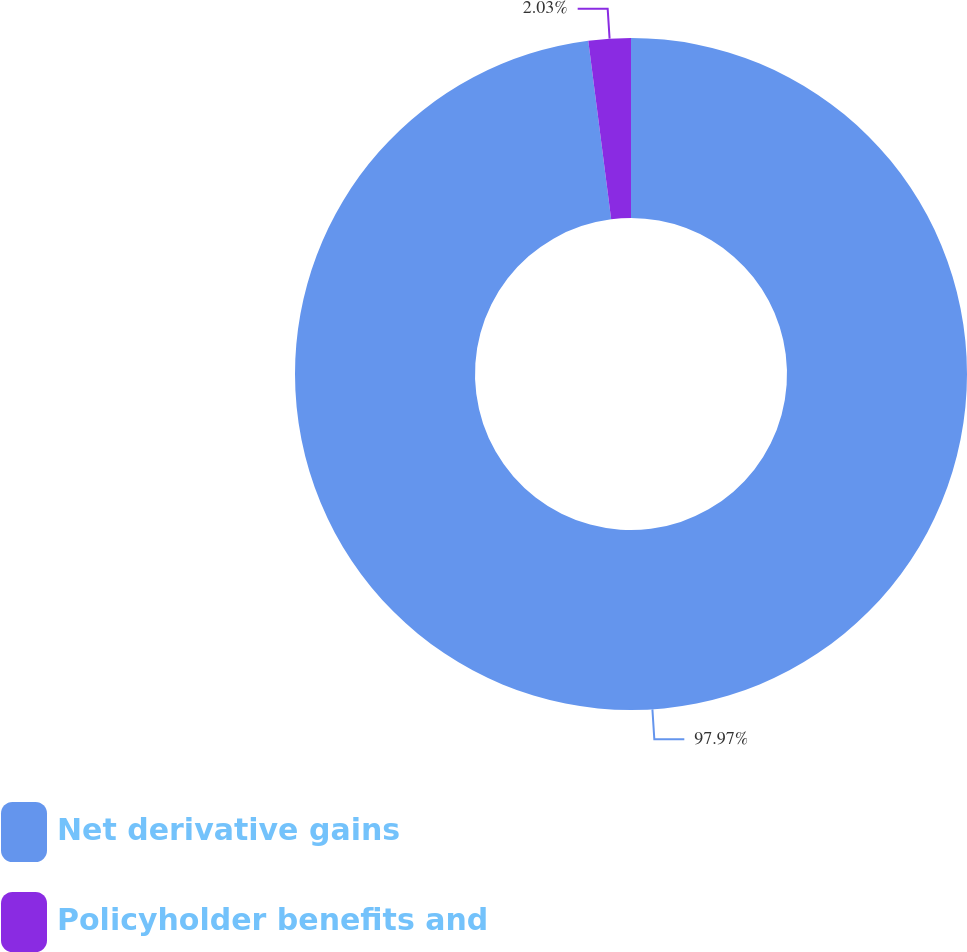Convert chart. <chart><loc_0><loc_0><loc_500><loc_500><pie_chart><fcel>Net derivative gains<fcel>Policyholder benefits and<nl><fcel>97.97%<fcel>2.03%<nl></chart> 